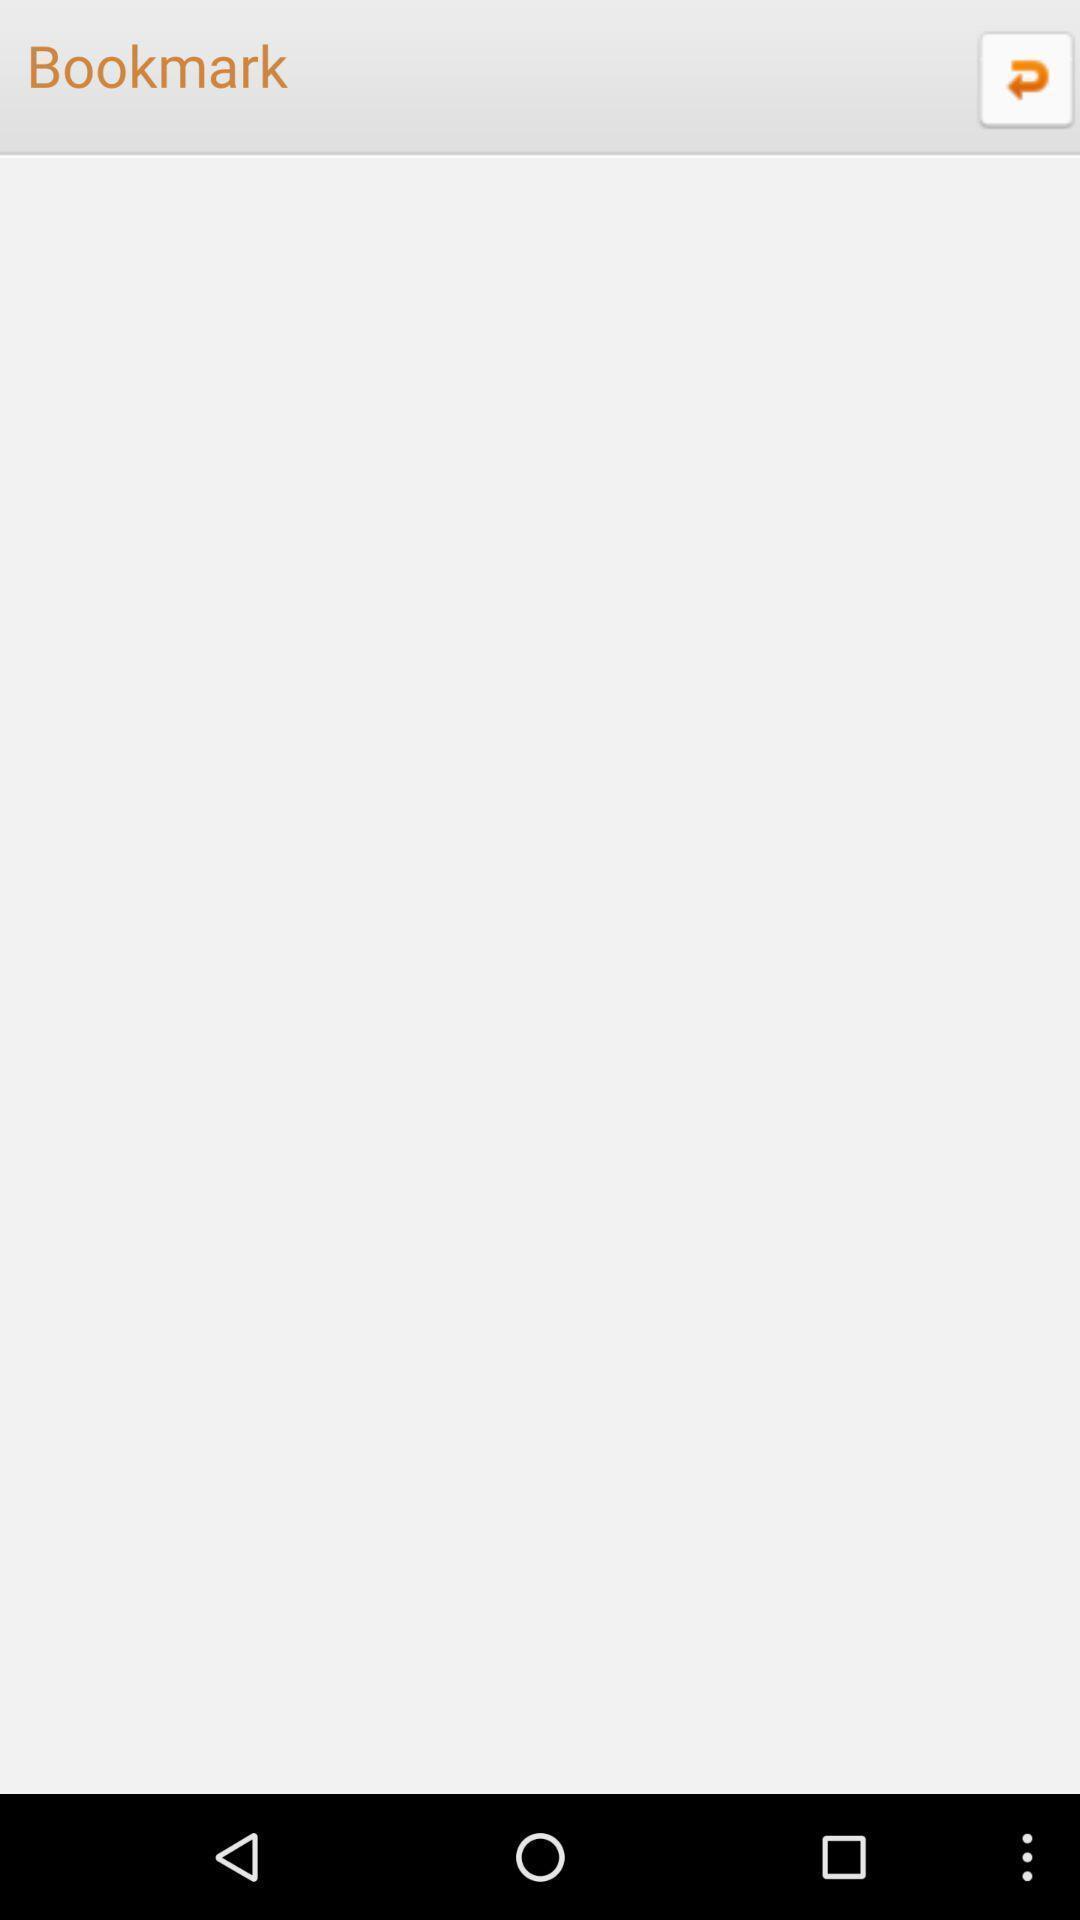Give me a summary of this screen capture. Screen showing a blank screen in bookmarks page. 